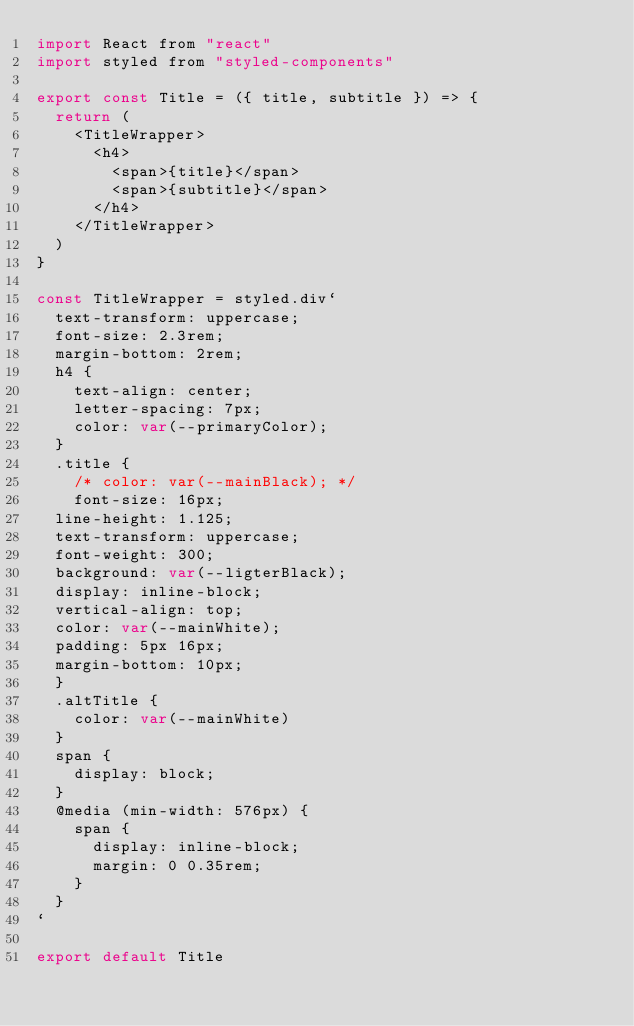<code> <loc_0><loc_0><loc_500><loc_500><_JavaScript_>import React from "react"
import styled from "styled-components"

export const Title = ({ title, subtitle }) => {
  return (
    <TitleWrapper>
      <h4>
        <span>{title}</span>
        <span>{subtitle}</span>
      </h4>
    </TitleWrapper>
  )
}

const TitleWrapper = styled.div`
  text-transform: uppercase;
  font-size: 2.3rem;
  margin-bottom: 2rem;
  h4 {
    text-align: center;
    letter-spacing: 7px;
    color: var(--primaryColor);
  }
  .title {
    /* color: var(--mainBlack); */
    font-size: 16px;
  line-height: 1.125;
  text-transform: uppercase;
  font-weight: 300;
  background: var(--ligterBlack);
  display: inline-block;
  vertical-align: top;
  color: var(--mainWhite);
  padding: 5px 16px;
  margin-bottom: 10px;
  }
  .altTitle {
    color: var(--mainWhite)
  }
  span {
    display: block;
  }
  @media (min-width: 576px) {
    span {
      display: inline-block;
      margin: 0 0.35rem;
    }
  }
`

export default Title


</code> 